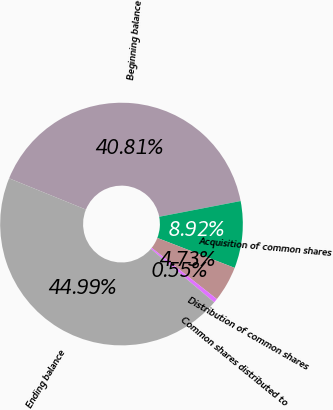<chart> <loc_0><loc_0><loc_500><loc_500><pie_chart><fcel>Beginning balance<fcel>Acquisition of common shares<fcel>Distribution of common shares<fcel>Common shares distributed to<fcel>Ending balance<nl><fcel>40.81%<fcel>8.92%<fcel>4.73%<fcel>0.55%<fcel>44.99%<nl></chart> 